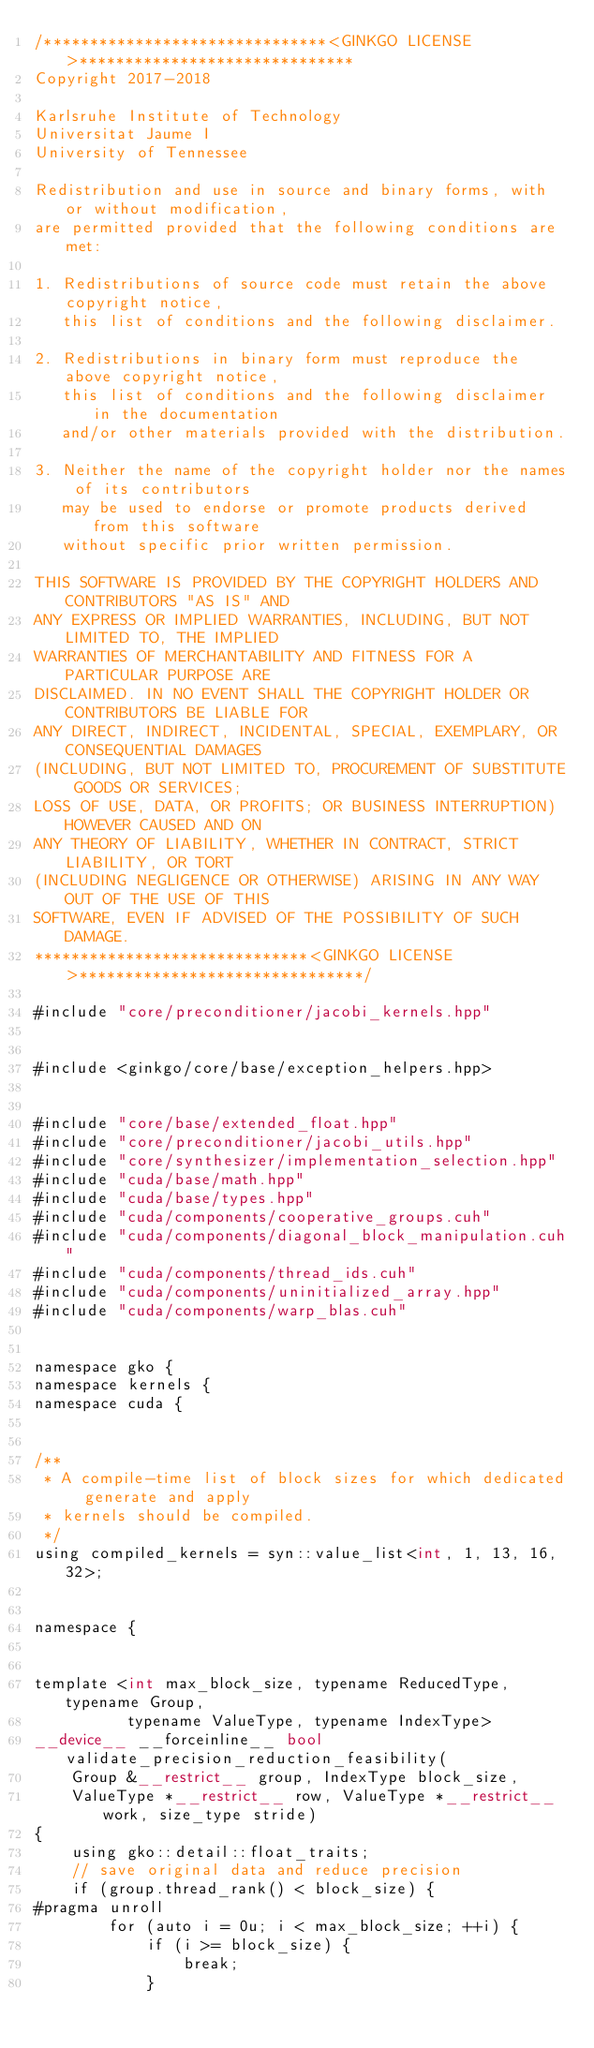<code> <loc_0><loc_0><loc_500><loc_500><_Cuda_>/*******************************<GINKGO LICENSE>******************************
Copyright 2017-2018

Karlsruhe Institute of Technology
Universitat Jaume I
University of Tennessee

Redistribution and use in source and binary forms, with or without modification,
are permitted provided that the following conditions are met:

1. Redistributions of source code must retain the above copyright notice,
   this list of conditions and the following disclaimer.

2. Redistributions in binary form must reproduce the above copyright notice,
   this list of conditions and the following disclaimer in the documentation
   and/or other materials provided with the distribution.

3. Neither the name of the copyright holder nor the names of its contributors
   may be used to endorse or promote products derived from this software
   without specific prior written permission.

THIS SOFTWARE IS PROVIDED BY THE COPYRIGHT HOLDERS AND CONTRIBUTORS "AS IS" AND
ANY EXPRESS OR IMPLIED WARRANTIES, INCLUDING, BUT NOT LIMITED TO, THE IMPLIED
WARRANTIES OF MERCHANTABILITY AND FITNESS FOR A PARTICULAR PURPOSE ARE
DISCLAIMED. IN NO EVENT SHALL THE COPYRIGHT HOLDER OR CONTRIBUTORS BE LIABLE FOR
ANY DIRECT, INDIRECT, INCIDENTAL, SPECIAL, EXEMPLARY, OR CONSEQUENTIAL DAMAGES
(INCLUDING, BUT NOT LIMITED TO, PROCUREMENT OF SUBSTITUTE GOODS OR SERVICES;
LOSS OF USE, DATA, OR PROFITS; OR BUSINESS INTERRUPTION) HOWEVER CAUSED AND ON
ANY THEORY OF LIABILITY, WHETHER IN CONTRACT, STRICT LIABILITY, OR TORT
(INCLUDING NEGLIGENCE OR OTHERWISE) ARISING IN ANY WAY OUT OF THE USE OF THIS
SOFTWARE, EVEN IF ADVISED OF THE POSSIBILITY OF SUCH DAMAGE.
******************************<GINKGO LICENSE>*******************************/

#include "core/preconditioner/jacobi_kernels.hpp"


#include <ginkgo/core/base/exception_helpers.hpp>


#include "core/base/extended_float.hpp"
#include "core/preconditioner/jacobi_utils.hpp"
#include "core/synthesizer/implementation_selection.hpp"
#include "cuda/base/math.hpp"
#include "cuda/base/types.hpp"
#include "cuda/components/cooperative_groups.cuh"
#include "cuda/components/diagonal_block_manipulation.cuh"
#include "cuda/components/thread_ids.cuh"
#include "cuda/components/uninitialized_array.hpp"
#include "cuda/components/warp_blas.cuh"


namespace gko {
namespace kernels {
namespace cuda {


/**
 * A compile-time list of block sizes for which dedicated generate and apply
 * kernels should be compiled.
 */
using compiled_kernels = syn::value_list<int, 1, 13, 16, 32>;


namespace {


template <int max_block_size, typename ReducedType, typename Group,
          typename ValueType, typename IndexType>
__device__ __forceinline__ bool validate_precision_reduction_feasibility(
    Group &__restrict__ group, IndexType block_size,
    ValueType *__restrict__ row, ValueType *__restrict__ work, size_type stride)
{
    using gko::detail::float_traits;
    // save original data and reduce precision
    if (group.thread_rank() < block_size) {
#pragma unroll
        for (auto i = 0u; i < max_block_size; ++i) {
            if (i >= block_size) {
                break;
            }</code> 